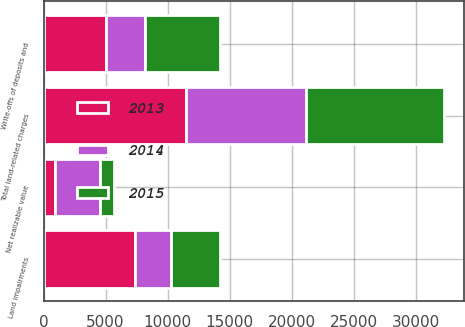Convert chart. <chart><loc_0><loc_0><loc_500><loc_500><stacked_bar_chart><ecel><fcel>Land impairments<fcel>Net realizable value<fcel>Write-offs of deposits and<fcel>Total land-related charges<nl><fcel>2013<fcel>7347<fcel>901<fcel>5021<fcel>11467<nl><fcel>2015<fcel>3911<fcel>1158<fcel>6099<fcel>11168<nl><fcel>2014<fcel>2944<fcel>3606<fcel>3122<fcel>9672<nl></chart> 